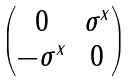Convert formula to latex. <formula><loc_0><loc_0><loc_500><loc_500>\begin{pmatrix} 0 & \sigma ^ { x } \\ - \sigma ^ { x } & 0 \end{pmatrix}</formula> 